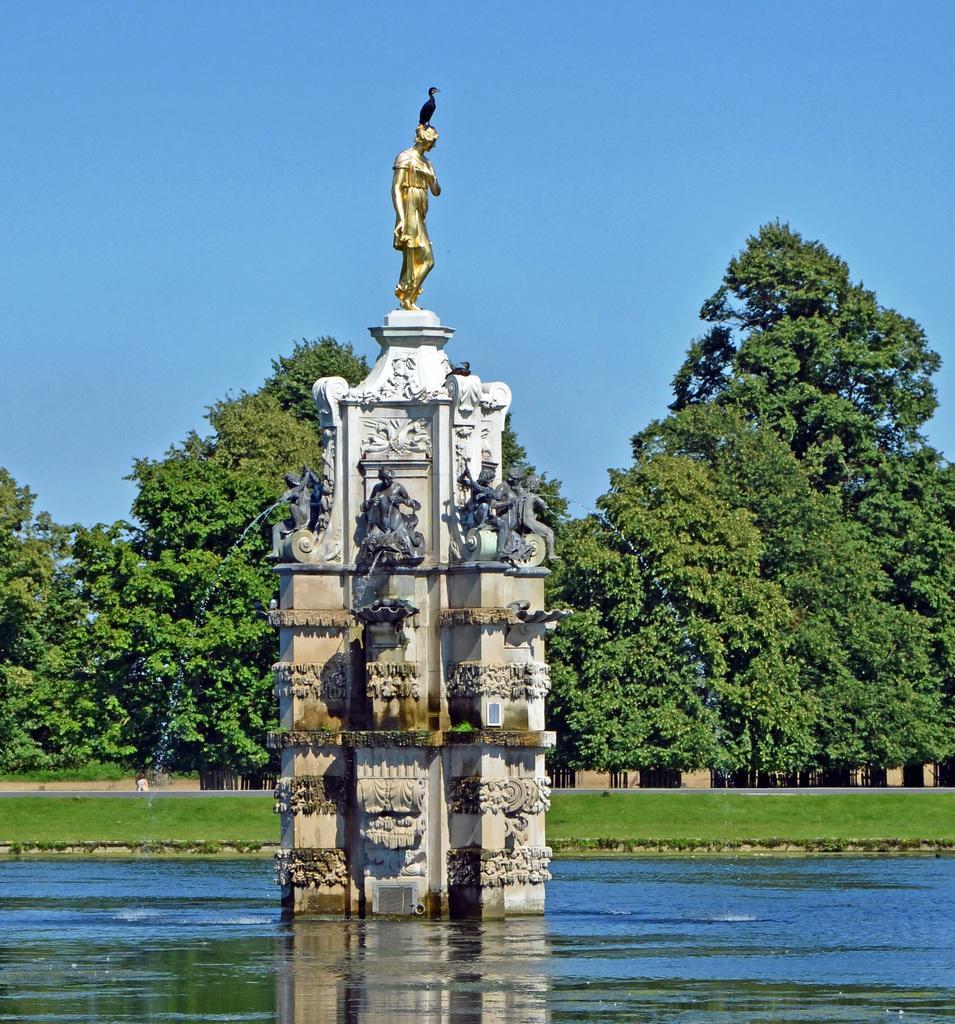Can you describe this image briefly? In this picture we can see statues, stone, water, and grass. In the background there are trees and sky. 